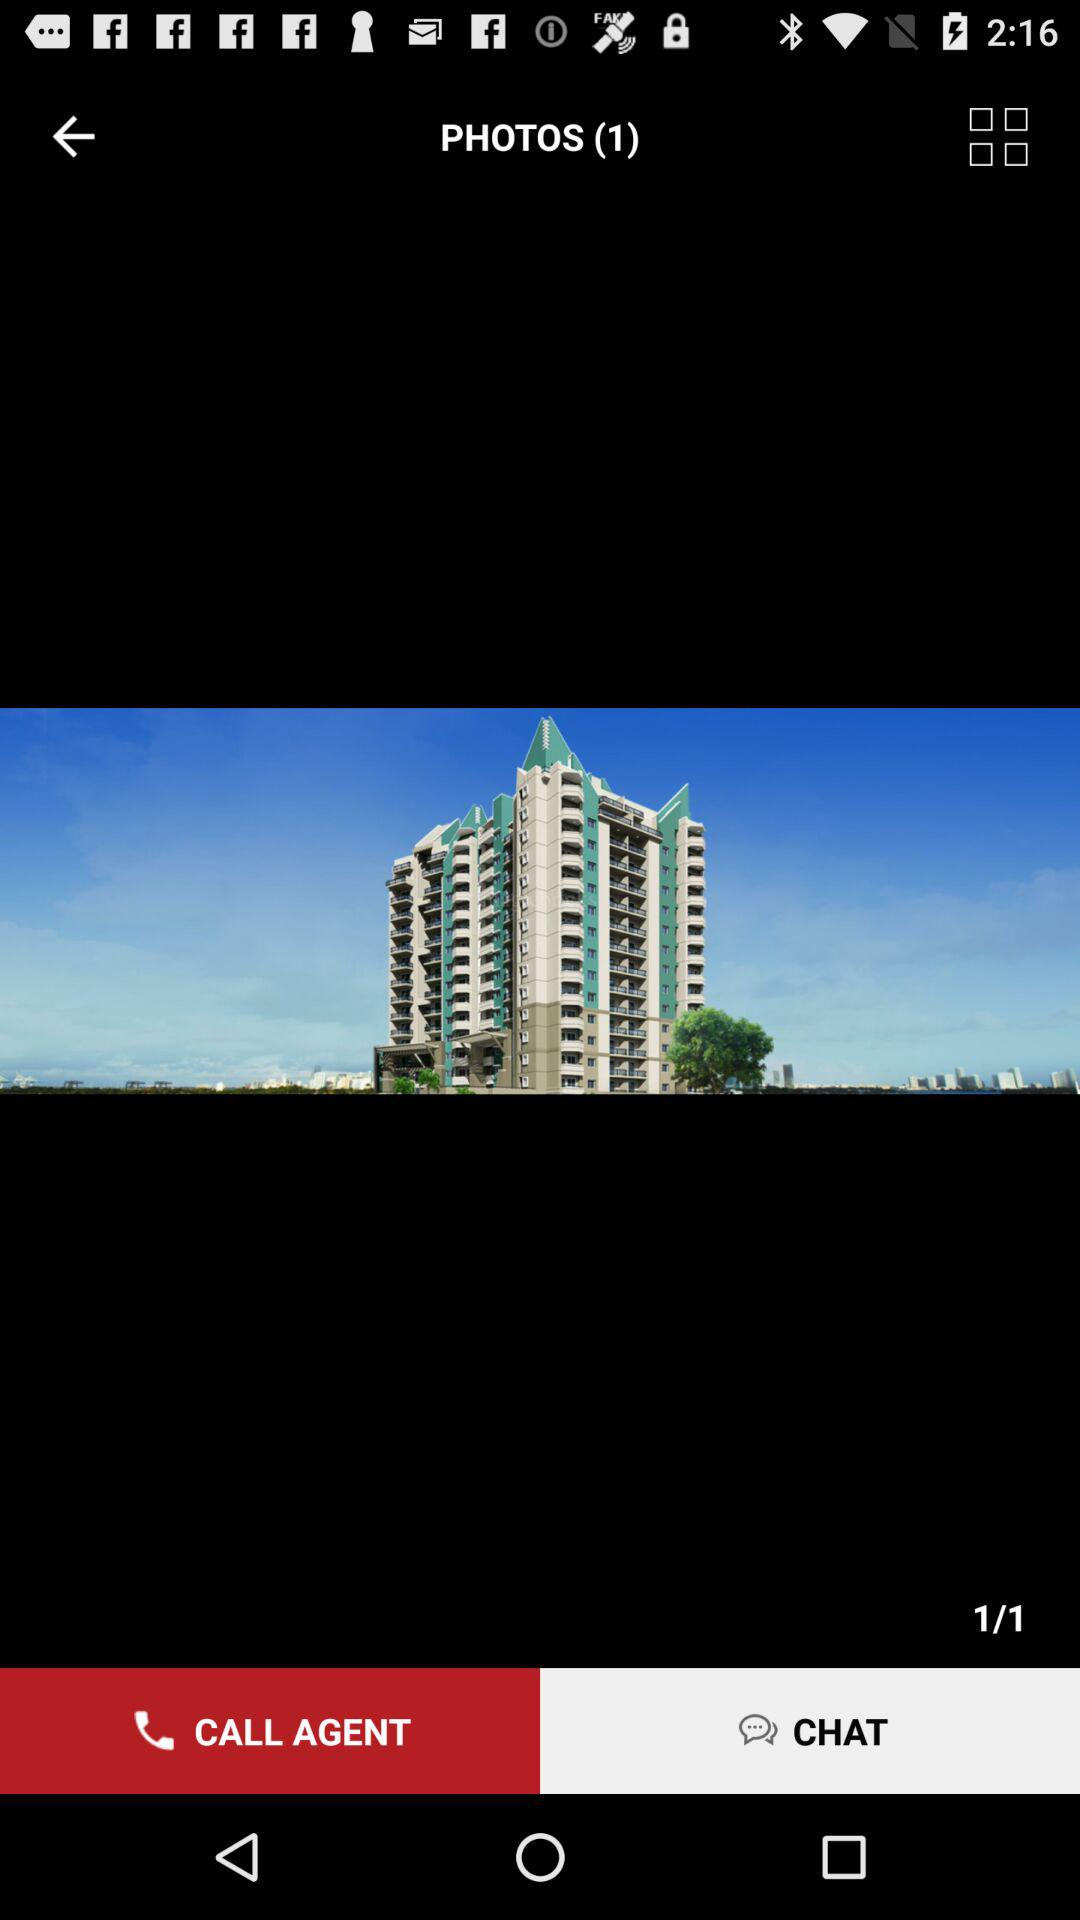How many photos are in the album?
Answer the question using a single word or phrase. 1 